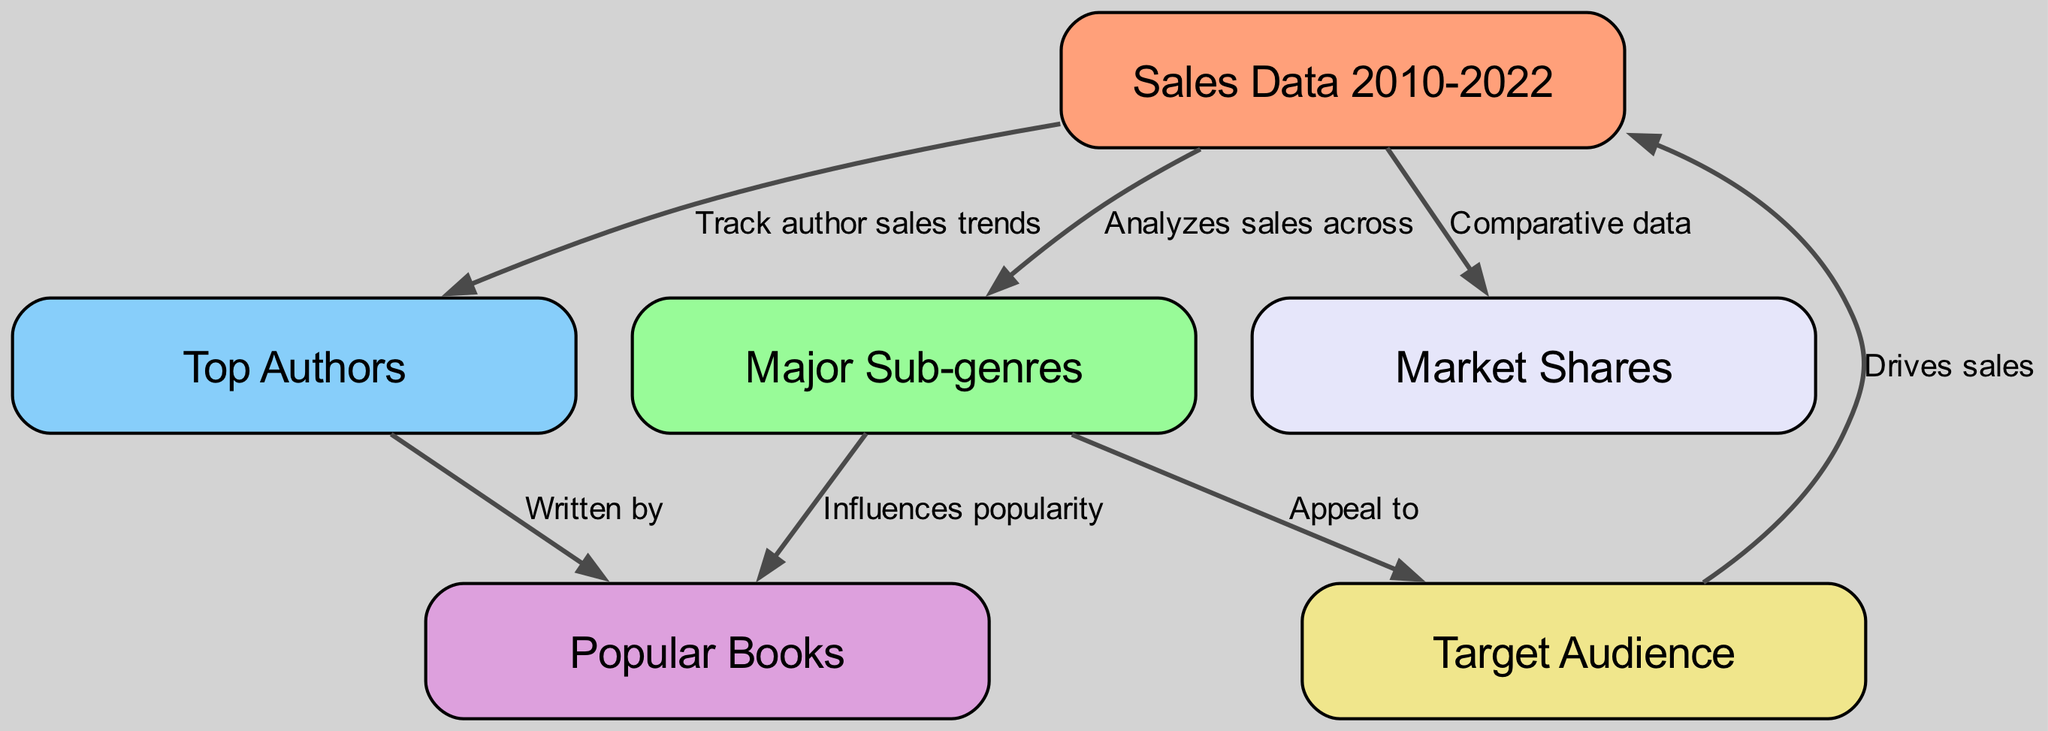What are the years covered in the sales data? The diagram indicates the sales data spans from 2010 to 2022, as inferred from the title and context provided in the description.
Answer: 2010-2022 How many major sub-genres are analyzed in the diagram? The diagram links to the node labeled "Major Sub-genres," which suggests various elements surrounding sub-genres; however, the exact number is not specified in the provided data but implies multiple categories.
Answer: Several Which node provides comparative data related to sales? The "Market Shares" node is connected via an edge labeled "Comparative data," indicating it provides comparative insights about the sales.
Answer: Market Shares What drives sales according to the diagram? The edge from "Target Audience" to "Sales Data" indicates that the target audience is the driving factor influencing sales trends.
Answer: Target Audience Which node is connected to "Popular Books"? The "Major Sub-genres" node influences the "Popular Books" node, as indicated by the connection labeled "Influences popularity."
Answer: Major Sub-genres Who are the top contributors to the popular books? The "Top Authors" node is connected to the "Popular Books" node with the edge "Written by," indicating that these authors are the main contributors.
Answer: Top Authors What aspect does the diagram track alongside author sales? The diagram tracks trends related to authors through the "Top Authors" node connected to the "Sales Data" node, showing a flow of information regarding their sales performance.
Answer: Author sales trends What influences the appeal of major sub-genres? The relationship between "Major Sub-genres" and "Target Audience" is indicated by the edge labeled "Appeal to," suggesting that the characteristics of the sub-genres greatly influence their appeal to different audiences.
Answer: Major Sub-genres How are sales data and author sales trends connected? The edge from "Sales Data" to "Top Authors" shows that the analysis of sales data also includes tracking trends related to the authors, indicating a direct relationship for insights.
Answer: Sales Data 